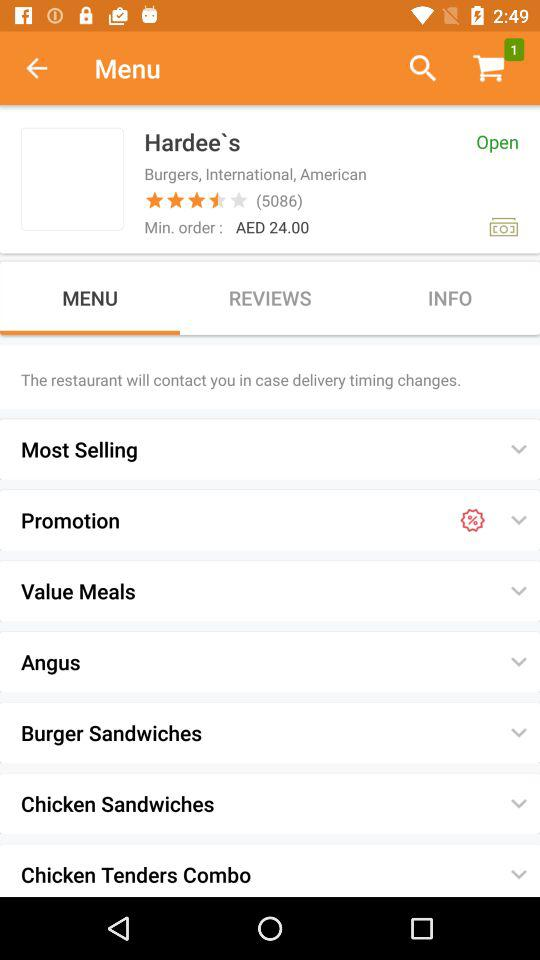How much is the minimum order?
Answer the question using a single word or phrase. AED 24.00 